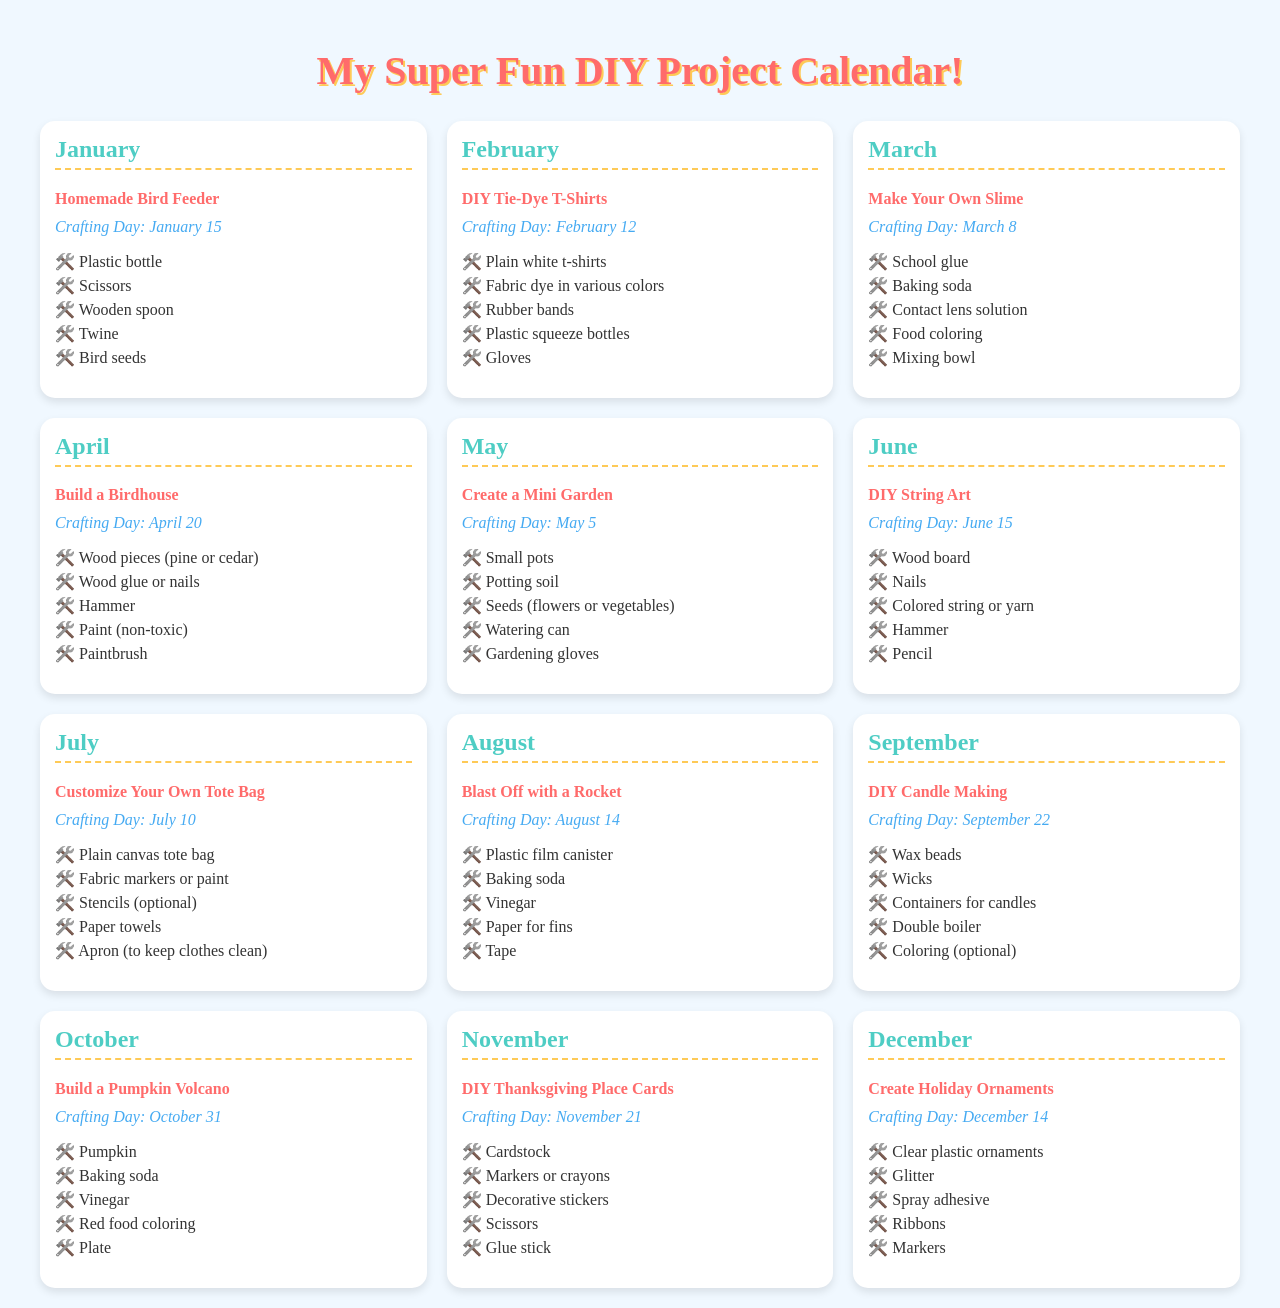What is the project for January? The project for January is stated clearly in the document as "Homemade Bird Feeder."
Answer: Homemade Bird Feeder When is the crafting day for March? The document provides a specific date for crafting in March, which is March 8.
Answer: March 8 How many projects are scheduled for the month of June? The document lists one project for June, which is "DIY String Art."
Answer: 1 What materials do you need for the August project? The document lists the materials for the August project "Blast Off with a Rocket."
Answer: Plastic film canister, Baking soda, Vinegar, Paper for fins, Tape Which project involves seeds? The project that includes seeds is detailed in the document as "Create a Mini Garden."
Answer: Create a Mini Garden What is the crafting day for November? The crafting day for November is specified as November 21 in the document.
Answer: November 21 Which month features the project for making candles? The document clearly states that DIY Candle Making is scheduled for September.
Answer: September What tool is needed for building a birdhouse? The document mentions hammer as a tool required for the April project "Build a Birdhouse."
Answer: Hammer What type of glue is used for the slime project? The document specifies that school glue is needed for the March project "Make Your Own Slime."
Answer: School glue 